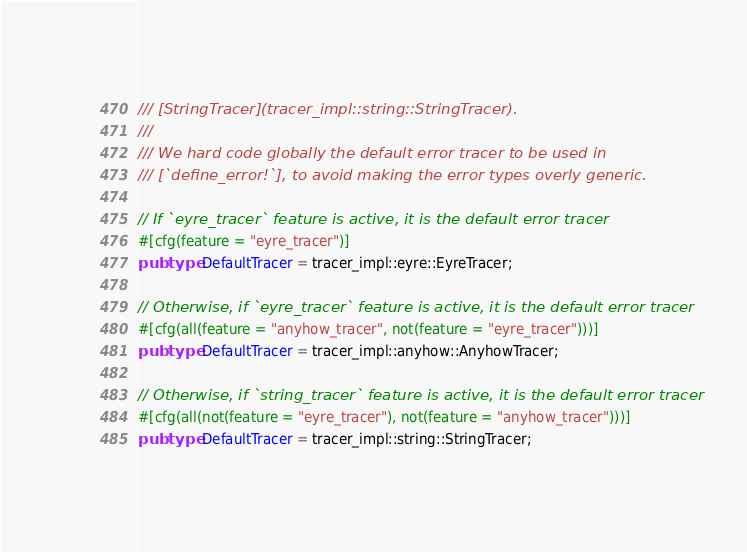<code> <loc_0><loc_0><loc_500><loc_500><_Rust_>/// [StringTracer](tracer_impl::string::StringTracer).
///
/// We hard code globally the default error tracer to be used in
/// [`define_error!`], to avoid making the error types overly generic.

// If `eyre_tracer` feature is active, it is the default error tracer
#[cfg(feature = "eyre_tracer")]
pub type DefaultTracer = tracer_impl::eyre::EyreTracer;

// Otherwise, if `eyre_tracer` feature is active, it is the default error tracer
#[cfg(all(feature = "anyhow_tracer", not(feature = "eyre_tracer")))]
pub type DefaultTracer = tracer_impl::anyhow::AnyhowTracer;

// Otherwise, if `string_tracer` feature is active, it is the default error tracer
#[cfg(all(not(feature = "eyre_tracer"), not(feature = "anyhow_tracer")))]
pub type DefaultTracer = tracer_impl::string::StringTracer;
</code> 